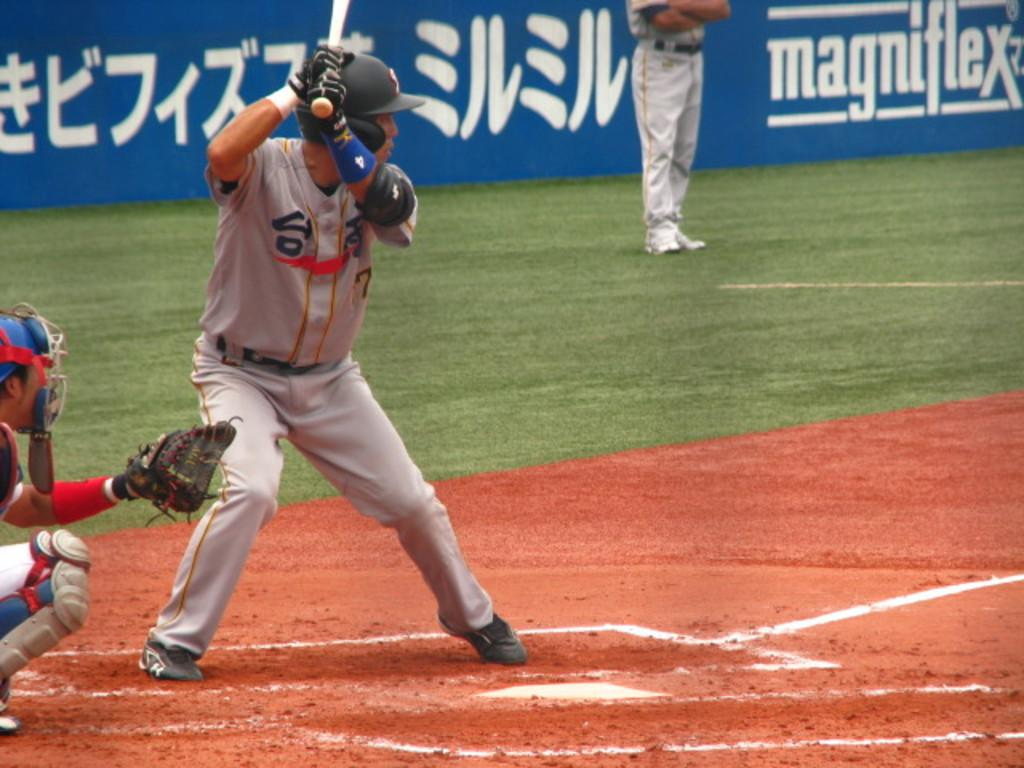<image>
Describe the image concisely. Japanese writing is next to the players as well as Magniflex 